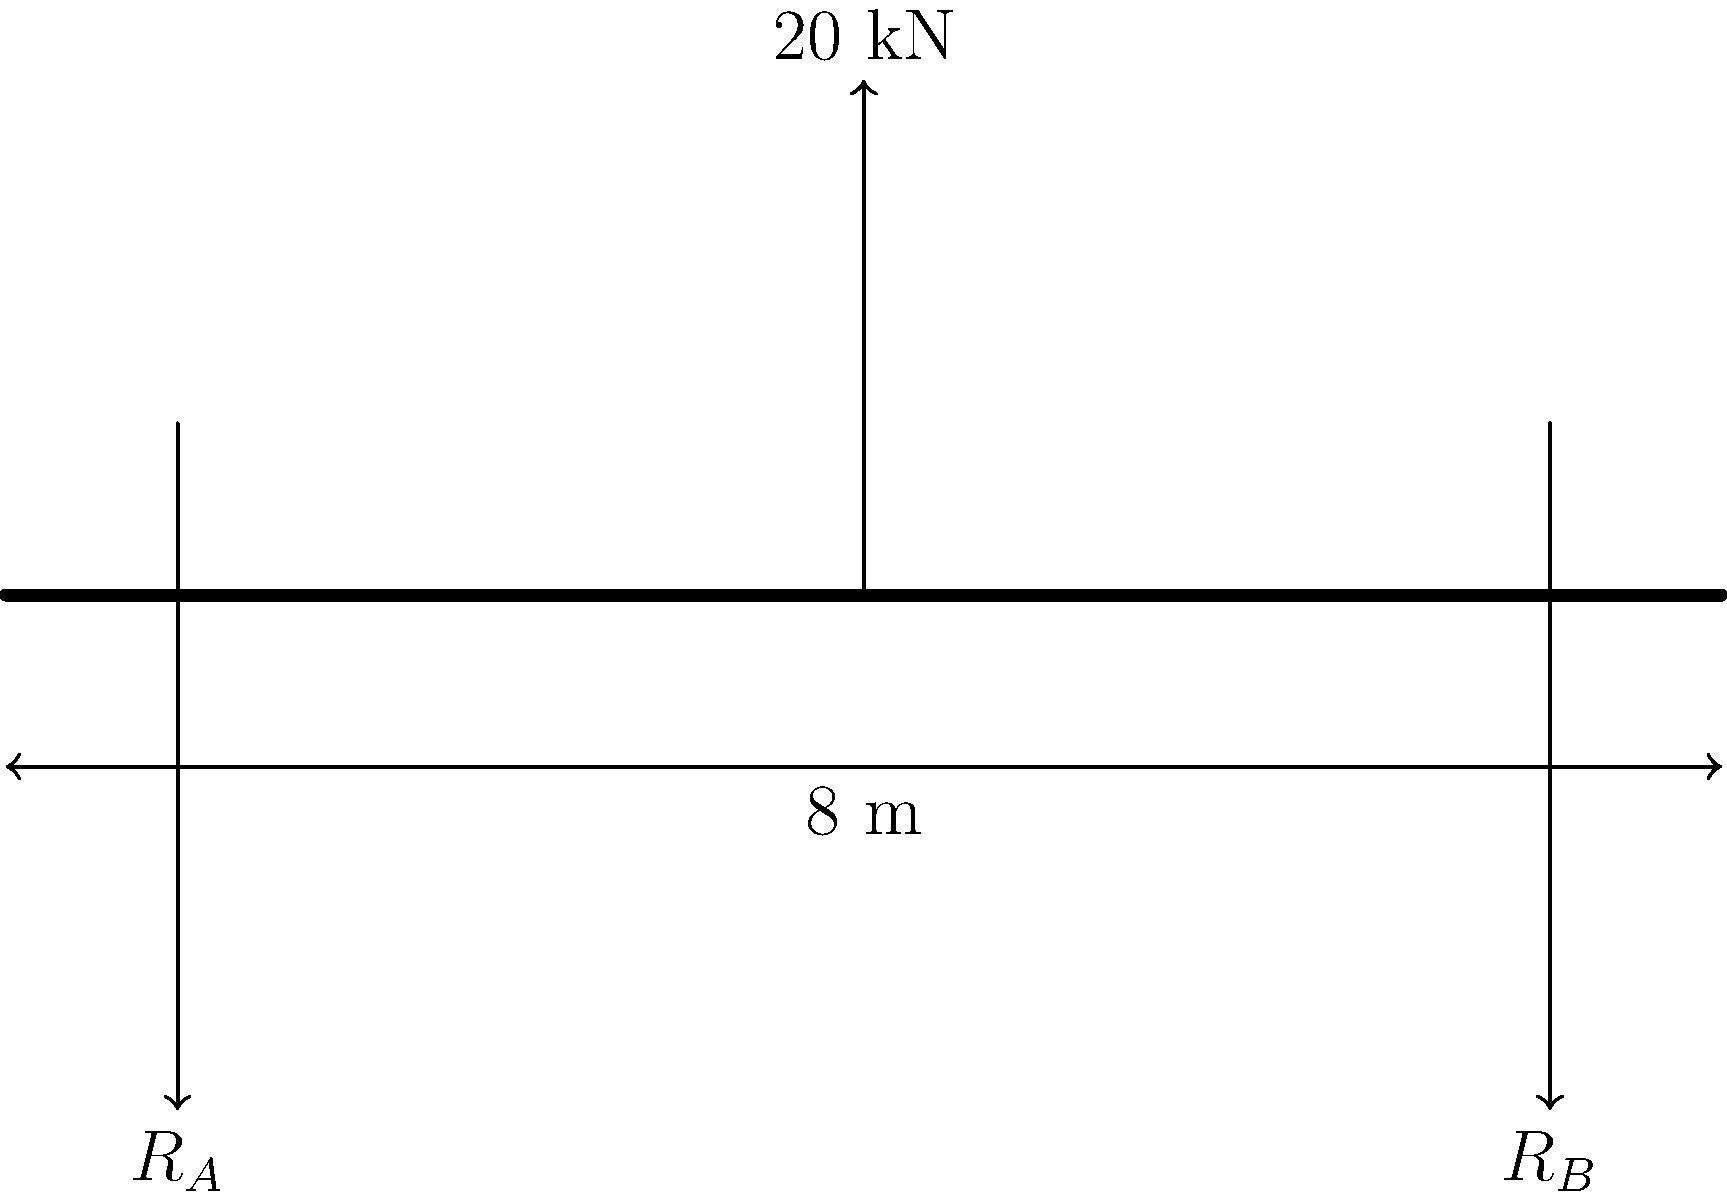As a civil engineer focused on structural resilience, analyze the simply supported beam shown in the figure. The beam spans 8 meters and is subjected to a point load of 20 kN at its midpoint. Calculate the maximum shear force and bending moment in the beam. How might understanding these forces contribute to designing more resilient structures? Let's approach this step-by-step:

1) First, calculate the reaction forces:
   Due to symmetry, $R_A = R_B = 10$ kN

2) Shear force diagram:
   - Left of the load: Constant shear force of 10 kN
   - Right of the load: Constant shear force of -10 kN
   The maximum shear force is 10 kN (absolute value)

3) Bending moment diagram:
   - Increases linearly from 0 at the supports to a maximum at the center
   - Maximum bending moment occurs at the center (x = 4 m)
   $M_{max} = R_A \cdot 4 = 10 \cdot 4 = 40$ kN·m

4) Understanding these forces contributes to designing more resilient structures by:
   - Identifying critical points of stress in the structure
   - Allowing for proper sizing of structural elements to withstand maximum loads
   - Enabling the selection of appropriate materials to resist shear and bending stresses
   - Facilitating the design of connections and supports to transfer loads effectively
   - Informing decisions on reinforcement placement in concrete structures

5) In innovative design, this understanding could lead to:
   - Optimized beam shapes that minimize material use while maximizing strength
   - Integration of smart materials that respond to load changes
   - Development of self-monitoring systems to detect excessive stresses in real-time
Answer: Maximum shear force: 10 kN; Maximum bending moment: 40 kN·m 